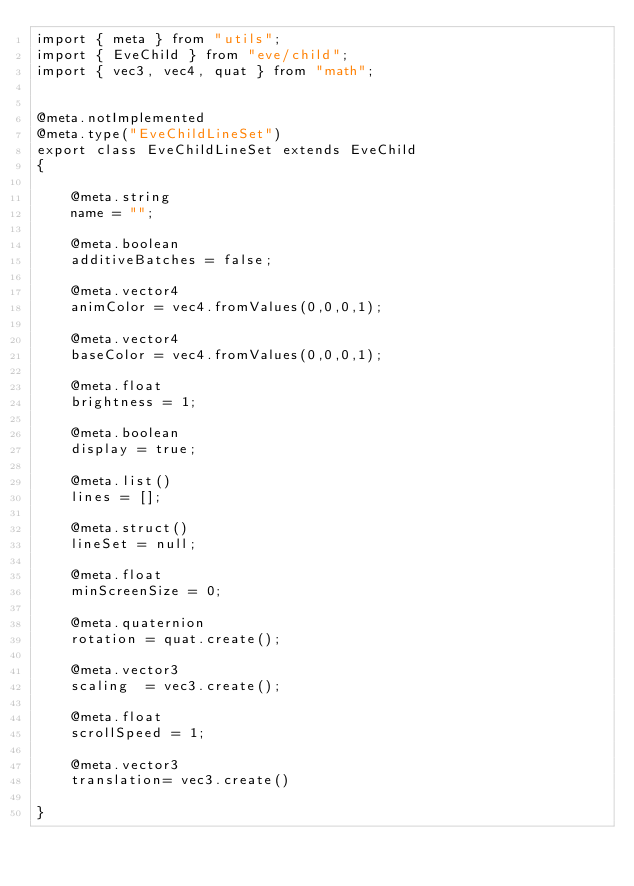<code> <loc_0><loc_0><loc_500><loc_500><_JavaScript_>import { meta } from "utils";
import { EveChild } from "eve/child";
import { vec3, vec4, quat } from "math";


@meta.notImplemented
@meta.type("EveChildLineSet")
export class EveChildLineSet extends EveChild
{

    @meta.string
    name = "";

    @meta.boolean
    additiveBatches = false;

    @meta.vector4
    animColor = vec4.fromValues(0,0,0,1);

    @meta.vector4
    baseColor = vec4.fromValues(0,0,0,1);

    @meta.float
    brightness = 1;

    @meta.boolean
    display = true;

    @meta.list()
    lines = [];

    @meta.struct()
    lineSet = null;

    @meta.float
    minScreenSize = 0;

    @meta.quaternion
    rotation = quat.create();

    @meta.vector3
    scaling  = vec3.create();

    @meta.float
    scrollSpeed = 1;

    @meta.vector3
    translation= vec3.create()

}
</code> 